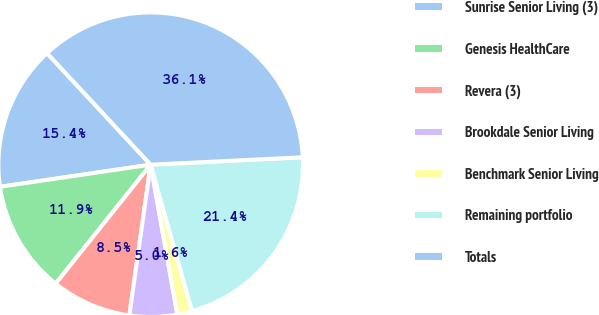Convert chart. <chart><loc_0><loc_0><loc_500><loc_500><pie_chart><fcel>Sunrise Senior Living (3)<fcel>Genesis HealthCare<fcel>Revera (3)<fcel>Brookdale Senior Living<fcel>Benchmark Senior Living<fcel>Remaining portfolio<fcel>Totals<nl><fcel>15.41%<fcel>11.95%<fcel>8.49%<fcel>5.04%<fcel>1.58%<fcel>21.39%<fcel>36.14%<nl></chart> 